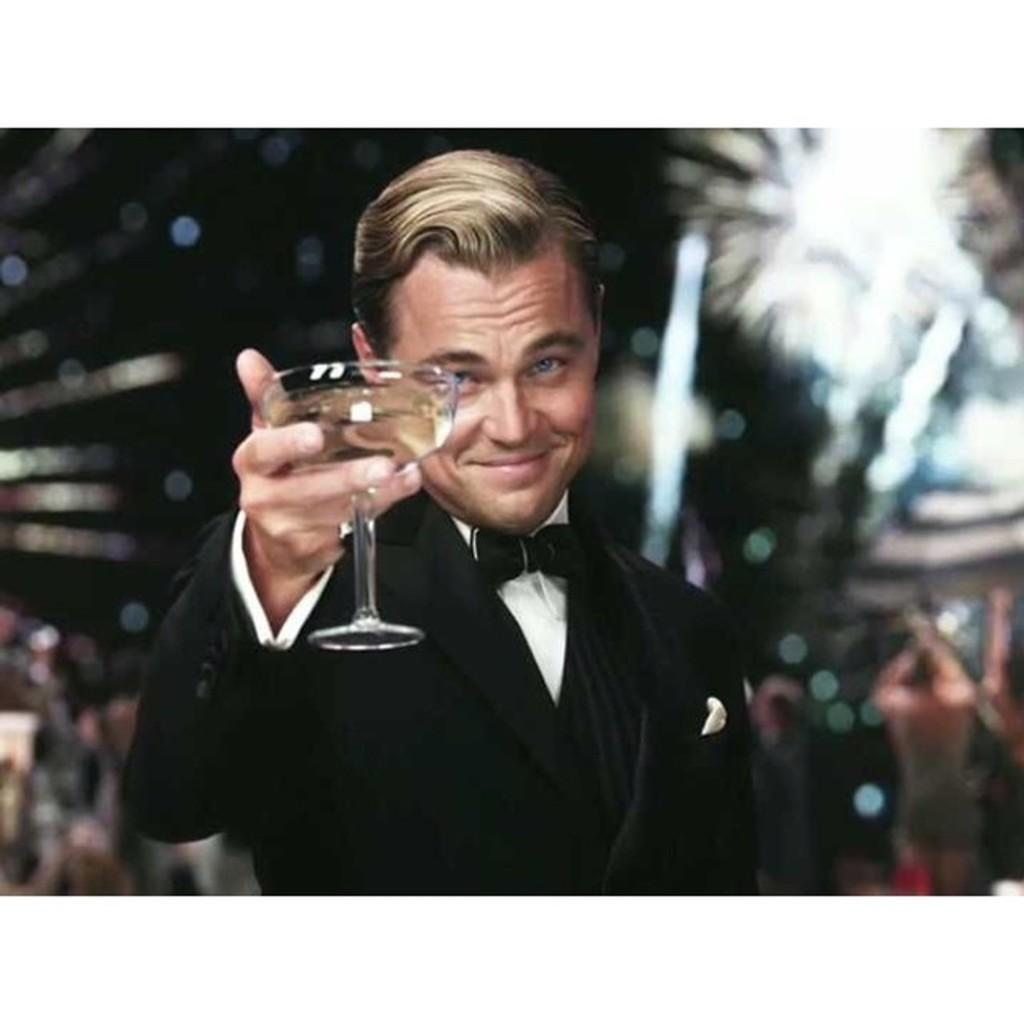Who is present in the image? There is a man in the image. What is the man doing with his hand? The man is raising a wine glass in his hand. What action is the man performing with the wine glass? The man is making cheers with the wine glass. How many people are in the group making cheers in the image? There is no group present in the image; it only features a single man making cheers. What type of comfort is the man experiencing in the image? The image does not provide information about the man's comfort level. 